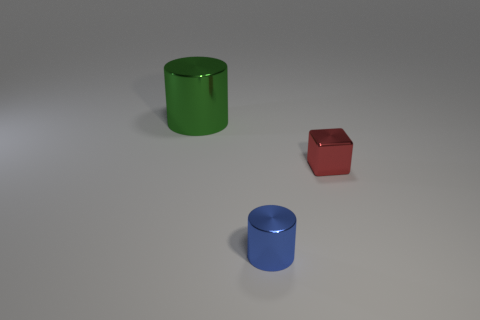Are there an equal number of tiny red things to the right of the big green metallic object and large cyan balls?
Keep it short and to the point. No. How many tiny cylinders are the same color as the large cylinder?
Offer a terse response. 0. What color is the big thing that is the same shape as the tiny blue thing?
Ensure brevity in your answer.  Green. Does the green metallic cylinder have the same size as the red cube?
Make the answer very short. No. Are there an equal number of blue shiny cylinders in front of the green metal thing and tiny shiny blocks on the right side of the red thing?
Provide a short and direct response. No. Is there a blue thing?
Ensure brevity in your answer.  Yes. The other metallic thing that is the same shape as the blue thing is what size?
Your answer should be compact. Large. There is a metallic object in front of the red thing; what size is it?
Keep it short and to the point. Small. Is the number of metallic objects that are on the right side of the green metal cylinder greater than the number of blue metal things?
Give a very brief answer. Yes. What shape is the small blue object?
Your answer should be compact. Cylinder. 